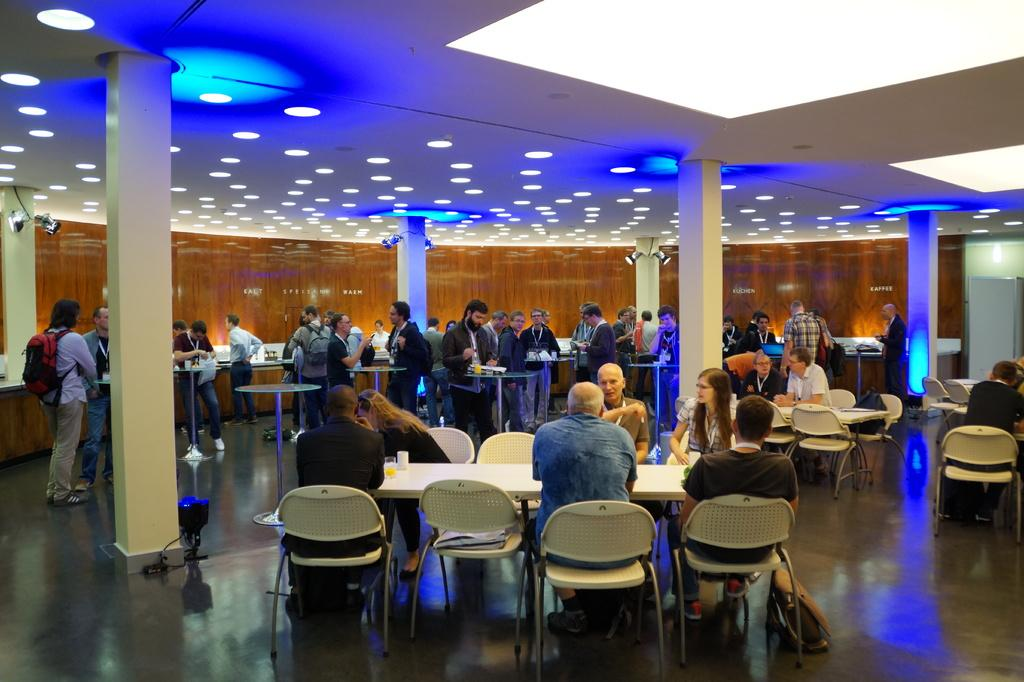How many people are present in the image? There are many people in the image. What are some of the people doing in the image? Some people are sitting, and some people are standing. What is a prominent feature in the image? There is a pillar in the image. What type of flame can be seen on the underwear of the person in the image? There is no flame or underwear visible in the image; it only shows people and a pillar. 